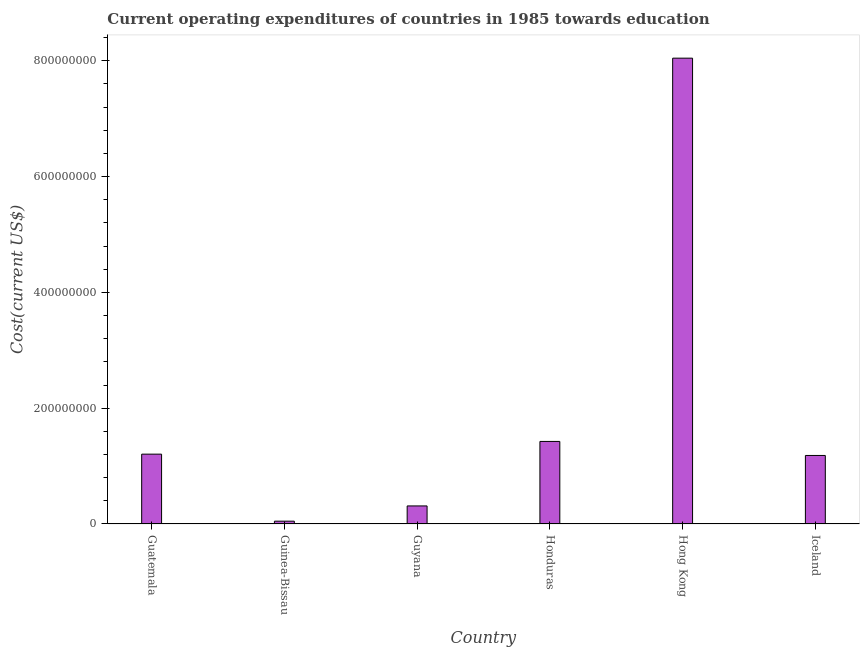Does the graph contain grids?
Your answer should be very brief. No. What is the title of the graph?
Offer a terse response. Current operating expenditures of countries in 1985 towards education. What is the label or title of the X-axis?
Provide a short and direct response. Country. What is the label or title of the Y-axis?
Give a very brief answer. Cost(current US$). What is the education expenditure in Guatemala?
Offer a terse response. 1.21e+08. Across all countries, what is the maximum education expenditure?
Ensure brevity in your answer.  8.04e+08. Across all countries, what is the minimum education expenditure?
Ensure brevity in your answer.  4.85e+06. In which country was the education expenditure maximum?
Keep it short and to the point. Hong Kong. In which country was the education expenditure minimum?
Give a very brief answer. Guinea-Bissau. What is the sum of the education expenditure?
Give a very brief answer. 1.22e+09. What is the difference between the education expenditure in Guinea-Bissau and Iceland?
Ensure brevity in your answer.  -1.13e+08. What is the average education expenditure per country?
Your response must be concise. 2.04e+08. What is the median education expenditure?
Your response must be concise. 1.19e+08. In how many countries, is the education expenditure greater than 480000000 US$?
Your answer should be compact. 1. What is the ratio of the education expenditure in Guatemala to that in Iceland?
Offer a terse response. 1.02. Is the difference between the education expenditure in Guyana and Honduras greater than the difference between any two countries?
Your response must be concise. No. What is the difference between the highest and the second highest education expenditure?
Your answer should be very brief. 6.62e+08. Is the sum of the education expenditure in Guyana and Hong Kong greater than the maximum education expenditure across all countries?
Offer a very short reply. Yes. What is the difference between the highest and the lowest education expenditure?
Make the answer very short. 8.00e+08. In how many countries, is the education expenditure greater than the average education expenditure taken over all countries?
Keep it short and to the point. 1. How many countries are there in the graph?
Your answer should be very brief. 6. Are the values on the major ticks of Y-axis written in scientific E-notation?
Ensure brevity in your answer.  No. What is the Cost(current US$) in Guatemala?
Give a very brief answer. 1.21e+08. What is the Cost(current US$) in Guinea-Bissau?
Your answer should be compact. 4.85e+06. What is the Cost(current US$) of Guyana?
Make the answer very short. 3.12e+07. What is the Cost(current US$) of Honduras?
Your answer should be compact. 1.43e+08. What is the Cost(current US$) of Hong Kong?
Keep it short and to the point. 8.04e+08. What is the Cost(current US$) in Iceland?
Offer a very short reply. 1.18e+08. What is the difference between the Cost(current US$) in Guatemala and Guinea-Bissau?
Keep it short and to the point. 1.16e+08. What is the difference between the Cost(current US$) in Guatemala and Guyana?
Your answer should be compact. 8.94e+07. What is the difference between the Cost(current US$) in Guatemala and Honduras?
Keep it short and to the point. -2.20e+07. What is the difference between the Cost(current US$) in Guatemala and Hong Kong?
Your answer should be very brief. -6.84e+08. What is the difference between the Cost(current US$) in Guatemala and Iceland?
Keep it short and to the point. 2.27e+06. What is the difference between the Cost(current US$) in Guinea-Bissau and Guyana?
Offer a terse response. -2.63e+07. What is the difference between the Cost(current US$) in Guinea-Bissau and Honduras?
Give a very brief answer. -1.38e+08. What is the difference between the Cost(current US$) in Guinea-Bissau and Hong Kong?
Provide a short and direct response. -8.00e+08. What is the difference between the Cost(current US$) in Guinea-Bissau and Iceland?
Your response must be concise. -1.13e+08. What is the difference between the Cost(current US$) in Guyana and Honduras?
Give a very brief answer. -1.11e+08. What is the difference between the Cost(current US$) in Guyana and Hong Kong?
Your answer should be compact. -7.73e+08. What is the difference between the Cost(current US$) in Guyana and Iceland?
Offer a very short reply. -8.71e+07. What is the difference between the Cost(current US$) in Honduras and Hong Kong?
Offer a very short reply. -6.62e+08. What is the difference between the Cost(current US$) in Honduras and Iceland?
Your answer should be very brief. 2.42e+07. What is the difference between the Cost(current US$) in Hong Kong and Iceland?
Your response must be concise. 6.86e+08. What is the ratio of the Cost(current US$) in Guatemala to that in Guinea-Bissau?
Your response must be concise. 24.86. What is the ratio of the Cost(current US$) in Guatemala to that in Guyana?
Your answer should be compact. 3.87. What is the ratio of the Cost(current US$) in Guatemala to that in Honduras?
Provide a short and direct response. 0.85. What is the ratio of the Cost(current US$) in Guatemala to that in Hong Kong?
Ensure brevity in your answer.  0.15. What is the ratio of the Cost(current US$) in Guinea-Bissau to that in Guyana?
Your answer should be very brief. 0.16. What is the ratio of the Cost(current US$) in Guinea-Bissau to that in Honduras?
Keep it short and to the point. 0.03. What is the ratio of the Cost(current US$) in Guinea-Bissau to that in Hong Kong?
Offer a terse response. 0.01. What is the ratio of the Cost(current US$) in Guinea-Bissau to that in Iceland?
Provide a succinct answer. 0.04. What is the ratio of the Cost(current US$) in Guyana to that in Honduras?
Your answer should be compact. 0.22. What is the ratio of the Cost(current US$) in Guyana to that in Hong Kong?
Make the answer very short. 0.04. What is the ratio of the Cost(current US$) in Guyana to that in Iceland?
Provide a succinct answer. 0.26. What is the ratio of the Cost(current US$) in Honduras to that in Hong Kong?
Offer a very short reply. 0.18. What is the ratio of the Cost(current US$) in Honduras to that in Iceland?
Provide a succinct answer. 1.21. What is the ratio of the Cost(current US$) in Hong Kong to that in Iceland?
Your answer should be compact. 6.8. 